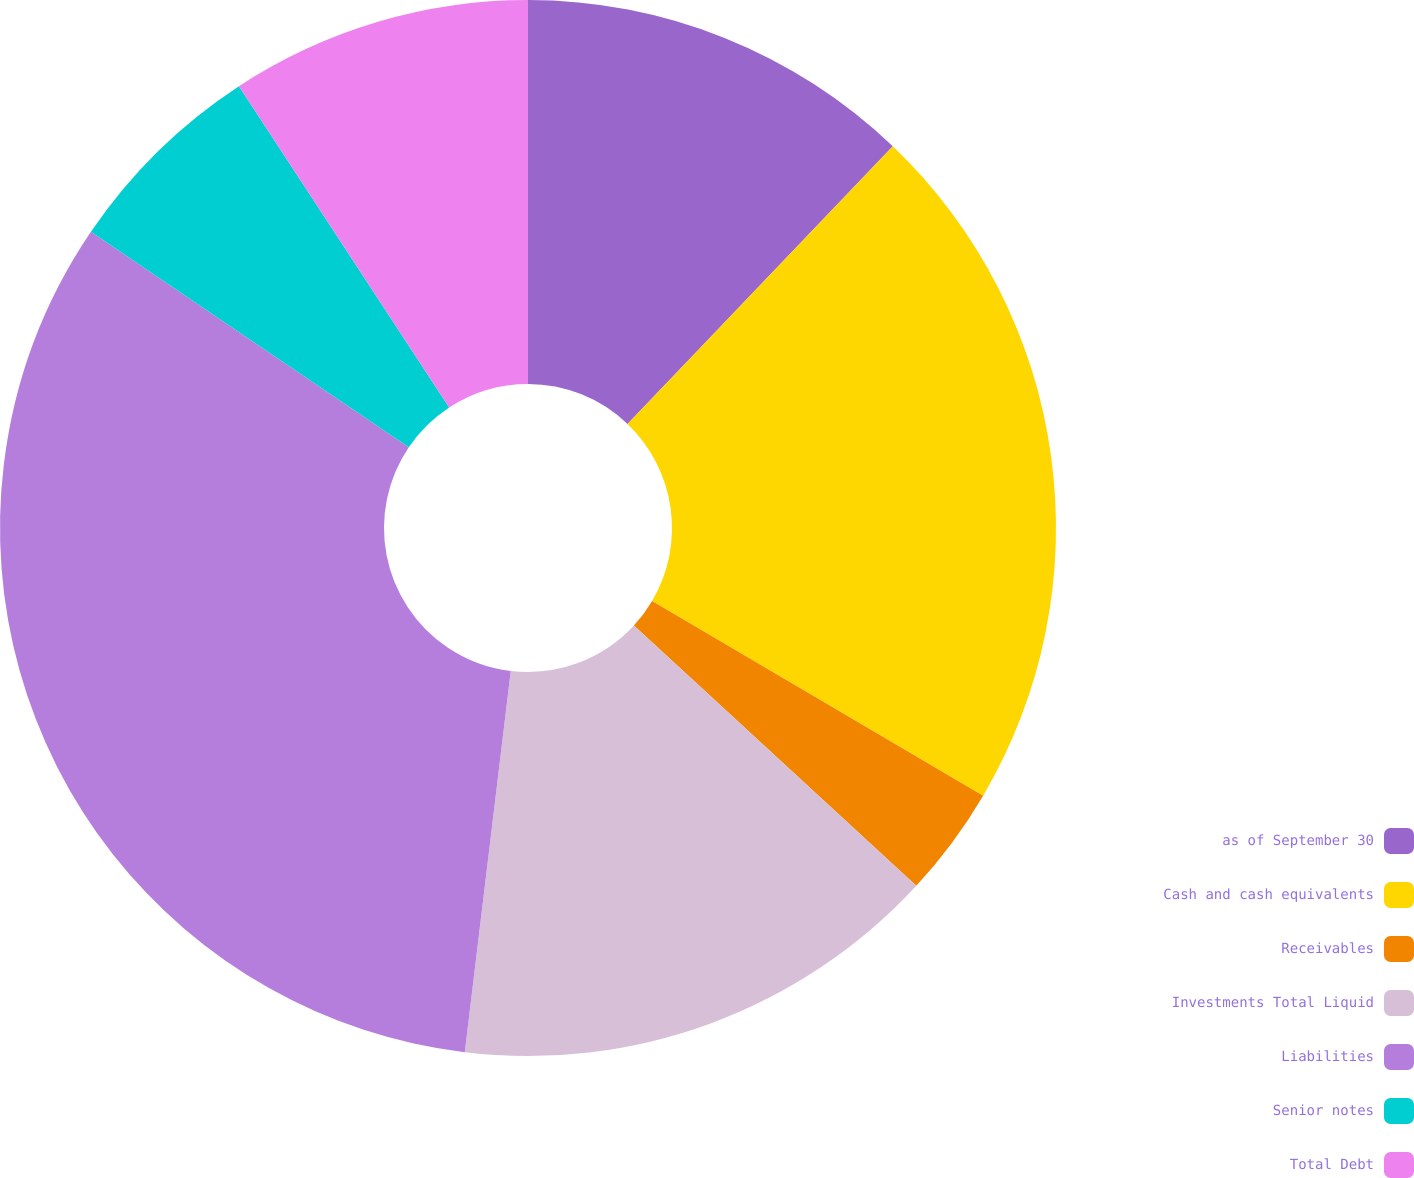Convert chart. <chart><loc_0><loc_0><loc_500><loc_500><pie_chart><fcel>as of September 30<fcel>Cash and cash equivalents<fcel>Receivables<fcel>Investments Total Liquid<fcel>Liabilities<fcel>Senior notes<fcel>Total Debt<nl><fcel>12.14%<fcel>21.32%<fcel>3.39%<fcel>15.06%<fcel>32.57%<fcel>6.3%<fcel>9.22%<nl></chart> 